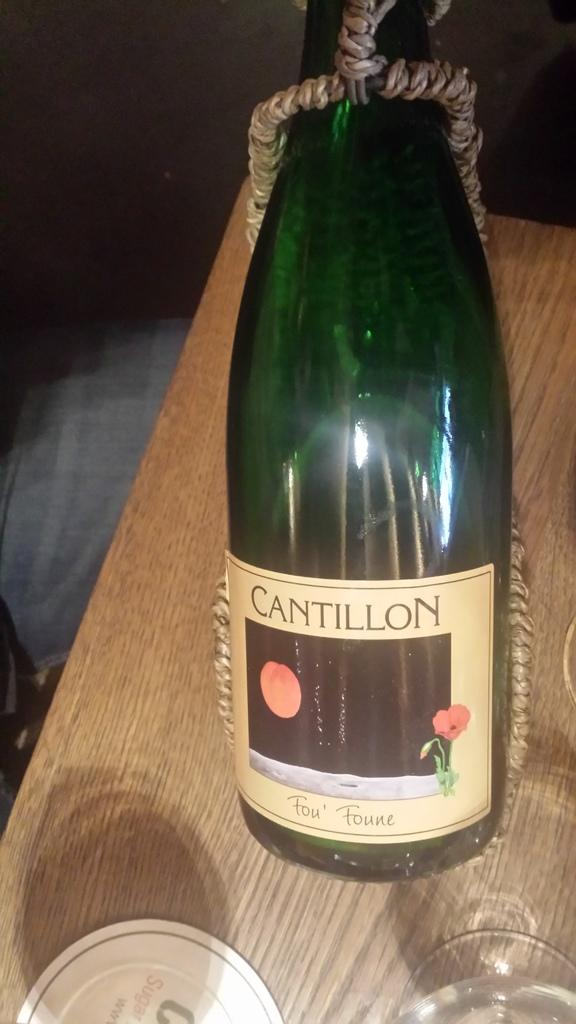Provide a one-sentence caption for the provided image. A bottle of Cantillon wine has a rope around it. 